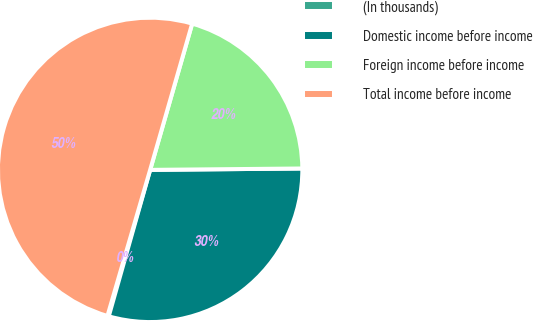<chart> <loc_0><loc_0><loc_500><loc_500><pie_chart><fcel>(In thousands)<fcel>Domestic income before income<fcel>Foreign income before income<fcel>Total income before income<nl><fcel>0.14%<fcel>29.53%<fcel>20.4%<fcel>49.93%<nl></chart> 